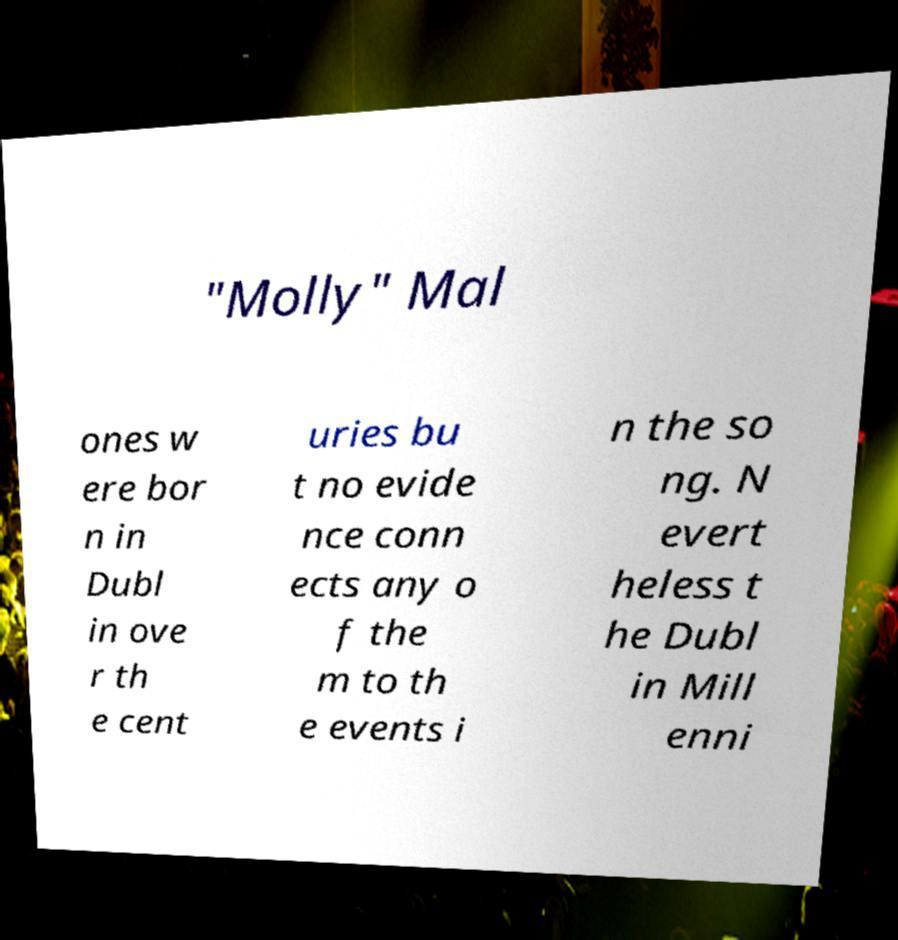Please read and relay the text visible in this image. What does it say? "Molly" Mal ones w ere bor n in Dubl in ove r th e cent uries bu t no evide nce conn ects any o f the m to th e events i n the so ng. N evert heless t he Dubl in Mill enni 